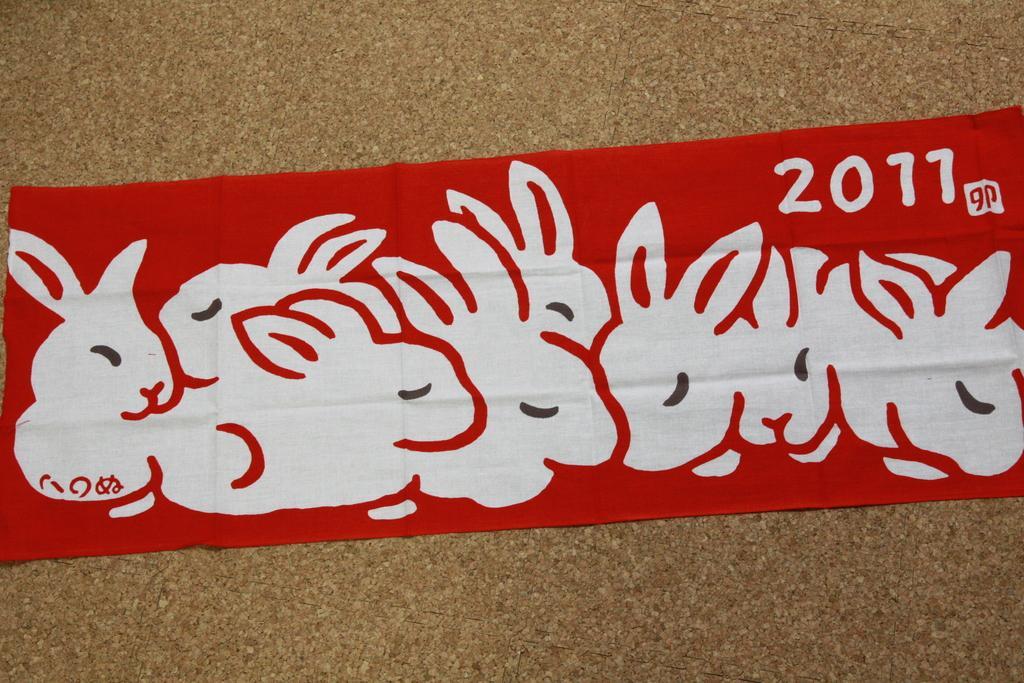Could you give a brief overview of what you see in this image? In this image we can see a printed ribbon. 